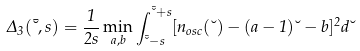<formula> <loc_0><loc_0><loc_500><loc_500>\Delta _ { 3 } ( \bar { \lambda } , s ) = \frac { 1 } { 2 s } \min _ { a , b } \int ^ { \bar { \lambda } + s } _ { \bar { \lambda } - s } [ n _ { o s c } ( \lambda ) - ( a - 1 ) \lambda - b ] ^ { 2 } d \lambda</formula> 